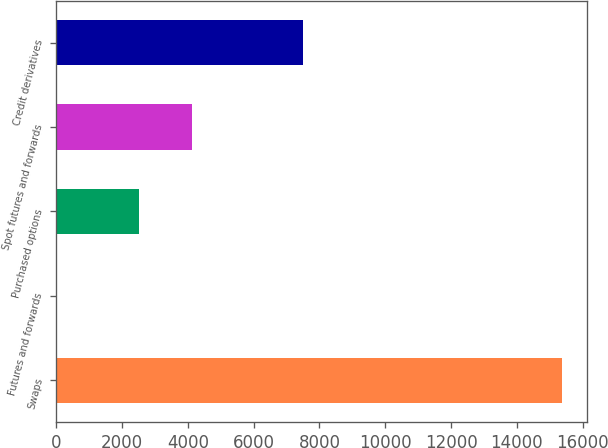Convert chart to OTSL. <chart><loc_0><loc_0><loc_500><loc_500><bar_chart><fcel>Swaps<fcel>Futures and forwards<fcel>Purchased options<fcel>Spot futures and forwards<fcel>Credit derivatives<nl><fcel>15368<fcel>10<fcel>2508<fcel>4124<fcel>7493<nl></chart> 